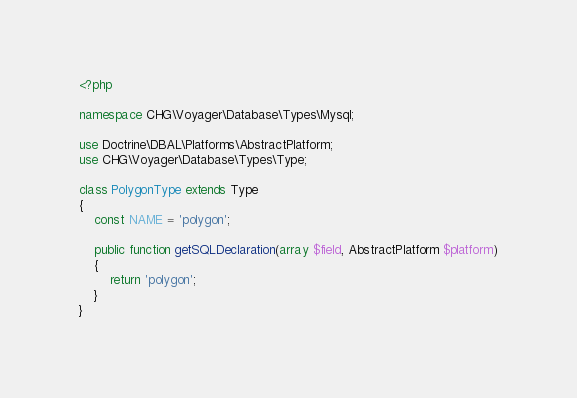Convert code to text. <code><loc_0><loc_0><loc_500><loc_500><_PHP_><?php

namespace CHG\Voyager\Database\Types\Mysql;

use Doctrine\DBAL\Platforms\AbstractPlatform;
use CHG\Voyager\Database\Types\Type;

class PolygonType extends Type
{
    const NAME = 'polygon';

    public function getSQLDeclaration(array $field, AbstractPlatform $platform)
    {
        return 'polygon';
    }
}
</code> 